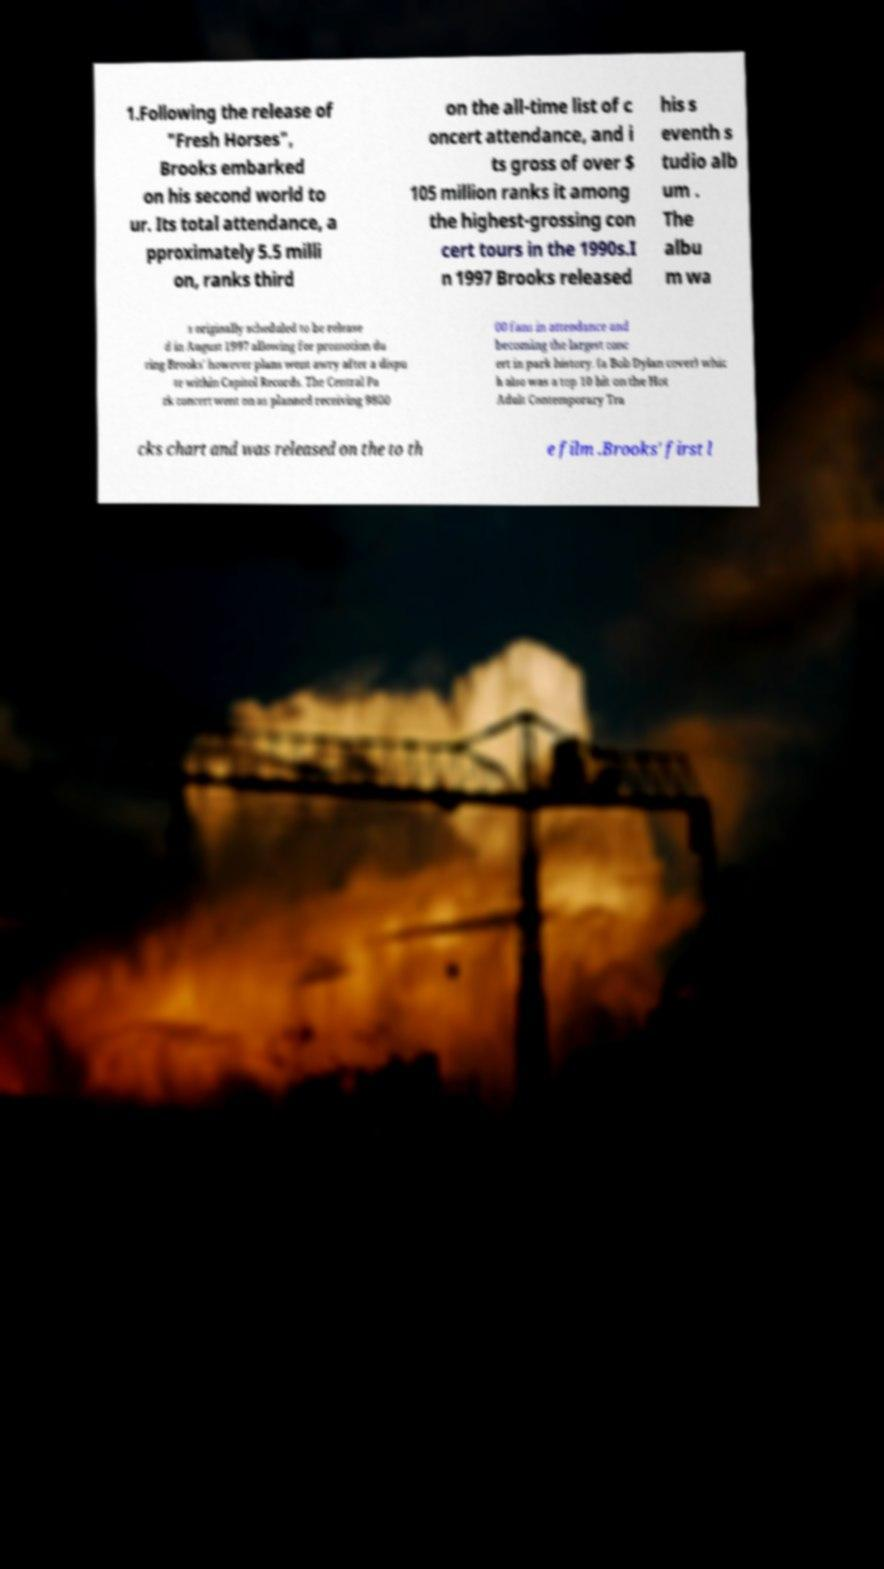Can you read and provide the text displayed in the image?This photo seems to have some interesting text. Can you extract and type it out for me? 1.Following the release of "Fresh Horses", Brooks embarked on his second world to ur. Its total attendance, a pproximately 5.5 milli on, ranks third on the all-time list of c oncert attendance, and i ts gross of over $ 105 million ranks it among the highest-grossing con cert tours in the 1990s.I n 1997 Brooks released his s eventh s tudio alb um . The albu m wa s originally scheduled to be release d in August 1997 allowing for promotion du ring Brooks' however plans went awry after a dispu te within Capitol Records. The Central Pa rk concert went on as planned receiving 9800 00 fans in attendance and becoming the largest conc ert in park history. (a Bob Dylan cover) whic h also was a top 10 hit on the Hot Adult Contemporary Tra cks chart and was released on the to th e film .Brooks' first l 